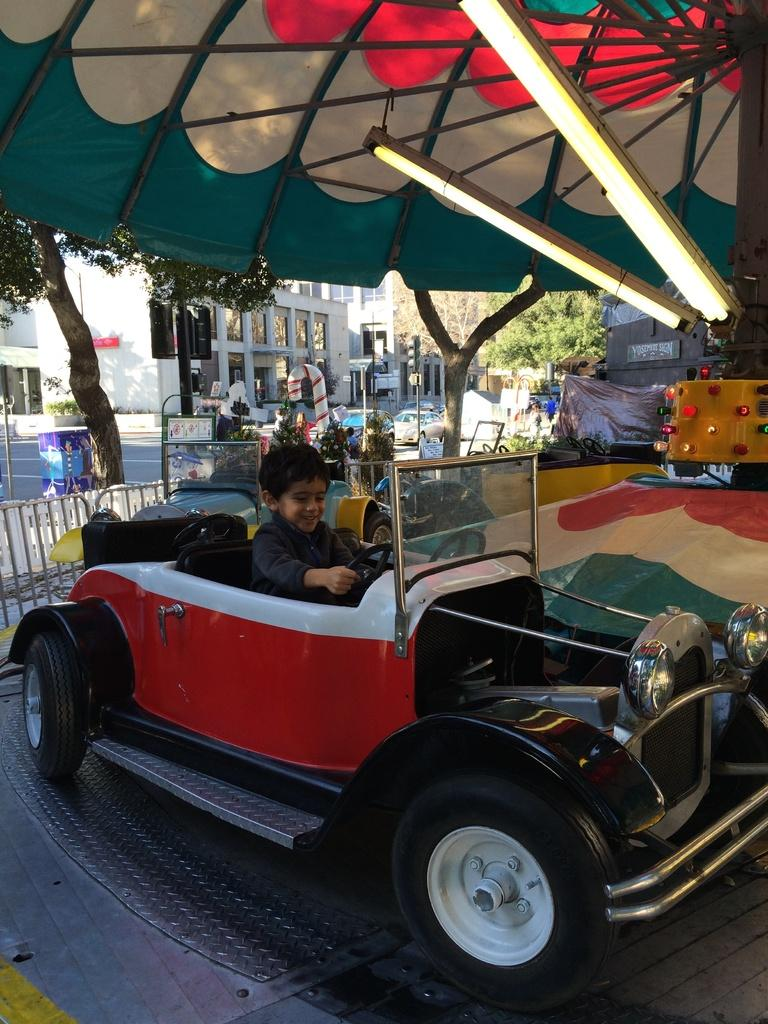What is the main subject of the image? There is a car in the image. Who or what is inside the car? A boy is sitting in the car. What can be seen in the background of the image? There is a tree, a road, a building, and more trees in the background of the image. What type of mask is the boy wearing in the image? There is no mask visible in the image; the boy is not wearing one. Is there a fight happening between the boy and the car in the image? No, there is no fight depicted in the image. The boy is simply sitting in the car. 